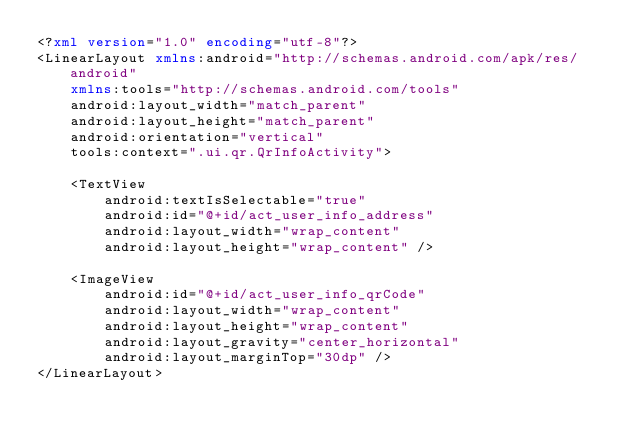Convert code to text. <code><loc_0><loc_0><loc_500><loc_500><_XML_><?xml version="1.0" encoding="utf-8"?>
<LinearLayout xmlns:android="http://schemas.android.com/apk/res/android"
    xmlns:tools="http://schemas.android.com/tools"
    android:layout_width="match_parent"
    android:layout_height="match_parent"
    android:orientation="vertical"
    tools:context=".ui.qr.QrInfoActivity">

    <TextView
        android:textIsSelectable="true"
        android:id="@+id/act_user_info_address"
        android:layout_width="wrap_content"
        android:layout_height="wrap_content" />

    <ImageView
        android:id="@+id/act_user_info_qrCode"
        android:layout_width="wrap_content"
        android:layout_height="wrap_content"
        android:layout_gravity="center_horizontal"
        android:layout_marginTop="30dp" />
</LinearLayout></code> 